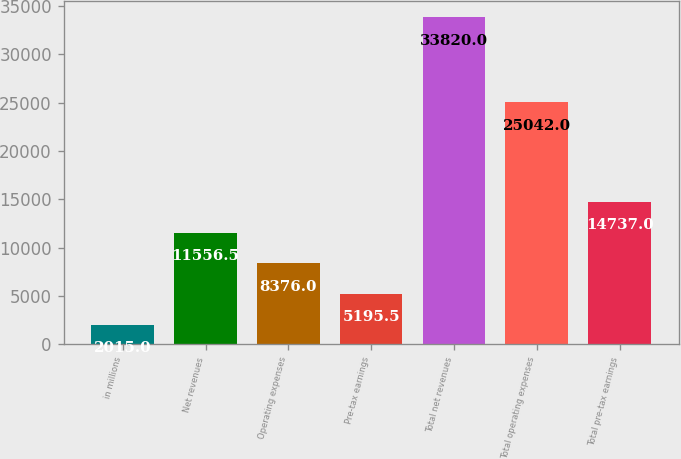Convert chart. <chart><loc_0><loc_0><loc_500><loc_500><bar_chart><fcel>in millions<fcel>Net revenues<fcel>Operating expenses<fcel>Pre-tax earnings<fcel>Total net revenues<fcel>Total operating expenses<fcel>Total pre-tax earnings<nl><fcel>2015<fcel>11556.5<fcel>8376<fcel>5195.5<fcel>33820<fcel>25042<fcel>14737<nl></chart> 